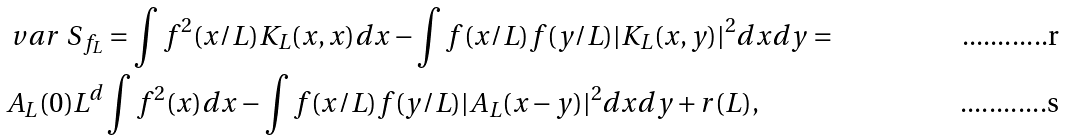<formula> <loc_0><loc_0><loc_500><loc_500>& \ v a r \ S _ { f _ { L } } = \int f ^ { 2 } ( x / L ) K _ { L } ( x , x ) d x - \int f ( x / L ) f ( y / L ) | K _ { L } ( x , y ) | ^ { 2 } d x d y = \\ & A _ { L } ( 0 ) L ^ { d } \int f ^ { 2 } ( x ) d x - \int f ( x / L ) f ( y / L ) | A _ { L } ( x - y ) | ^ { 2 } d x d y + r ( L ) ,</formula> 